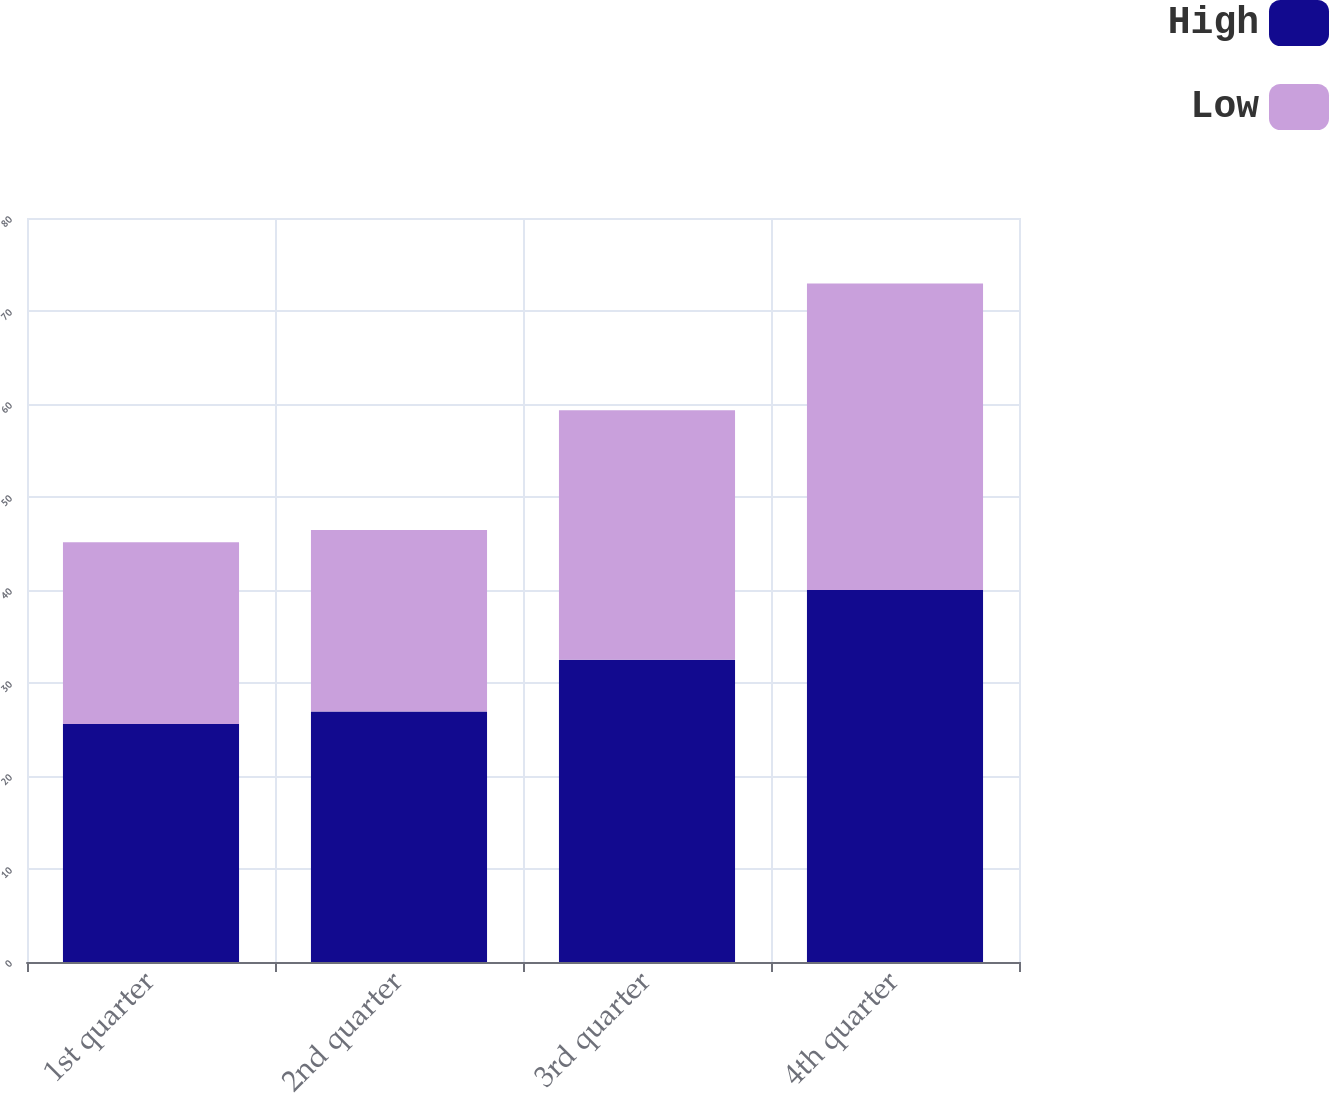Convert chart. <chart><loc_0><loc_0><loc_500><loc_500><stacked_bar_chart><ecel><fcel>1st quarter<fcel>2nd quarter<fcel>3rd quarter<fcel>4th quarter<nl><fcel>High<fcel>25.59<fcel>26.94<fcel>32.5<fcel>40<nl><fcel>Low<fcel>19.55<fcel>19.52<fcel>26.83<fcel>32.95<nl></chart> 